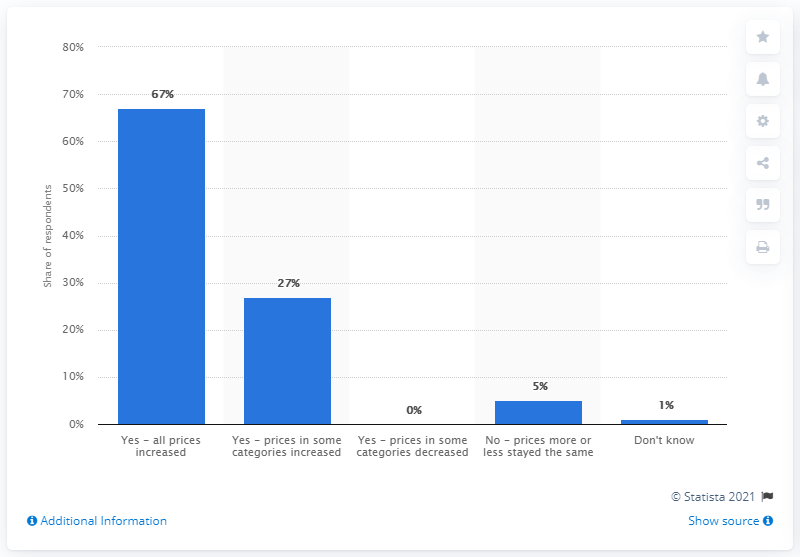Give some essential details in this illustration. Sixty-seven percent of respondents reported that all prices had increased. In a survey of respondents regarding the impact of the changeover, 27% reported that prices in certain categories had increased at the time of the changeover. 